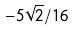<formula> <loc_0><loc_0><loc_500><loc_500>- 5 \sqrt { 2 } / 1 6</formula> 